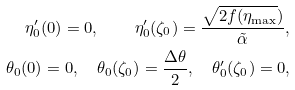<formula> <loc_0><loc_0><loc_500><loc_500>\eta _ { 0 } ^ { \prime } ( 0 ) = 0 , \quad \eta _ { 0 } ^ { \prime } ( \zeta _ { 0 } ) = \frac { \sqrt { 2 f ( \eta _ { \max } } ) } { \tilde { \alpha } } , \\ \theta _ { 0 } ( 0 ) = 0 , \quad \theta _ { 0 } ( \zeta _ { 0 } ) = \frac { \Delta \theta } { 2 } , \quad \theta _ { 0 } ^ { \prime } ( \zeta _ { 0 } ) = 0 ,</formula> 